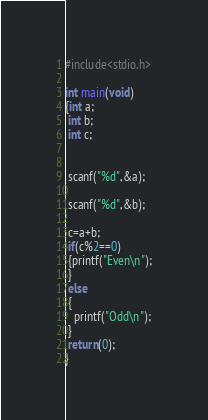Convert code to text. <code><loc_0><loc_0><loc_500><loc_500><_C_>#include<stdio.h>

int main(void)
{int a;
 int b;
 int c;


 scanf("%d",&a);
 
 scanf("%d",&b);

 c=a+b;
 if(c%2==0)
 {printf("Even\n");
 }
 else
 {
   printf("Odd\n");
 }
 return(0);
}</code> 